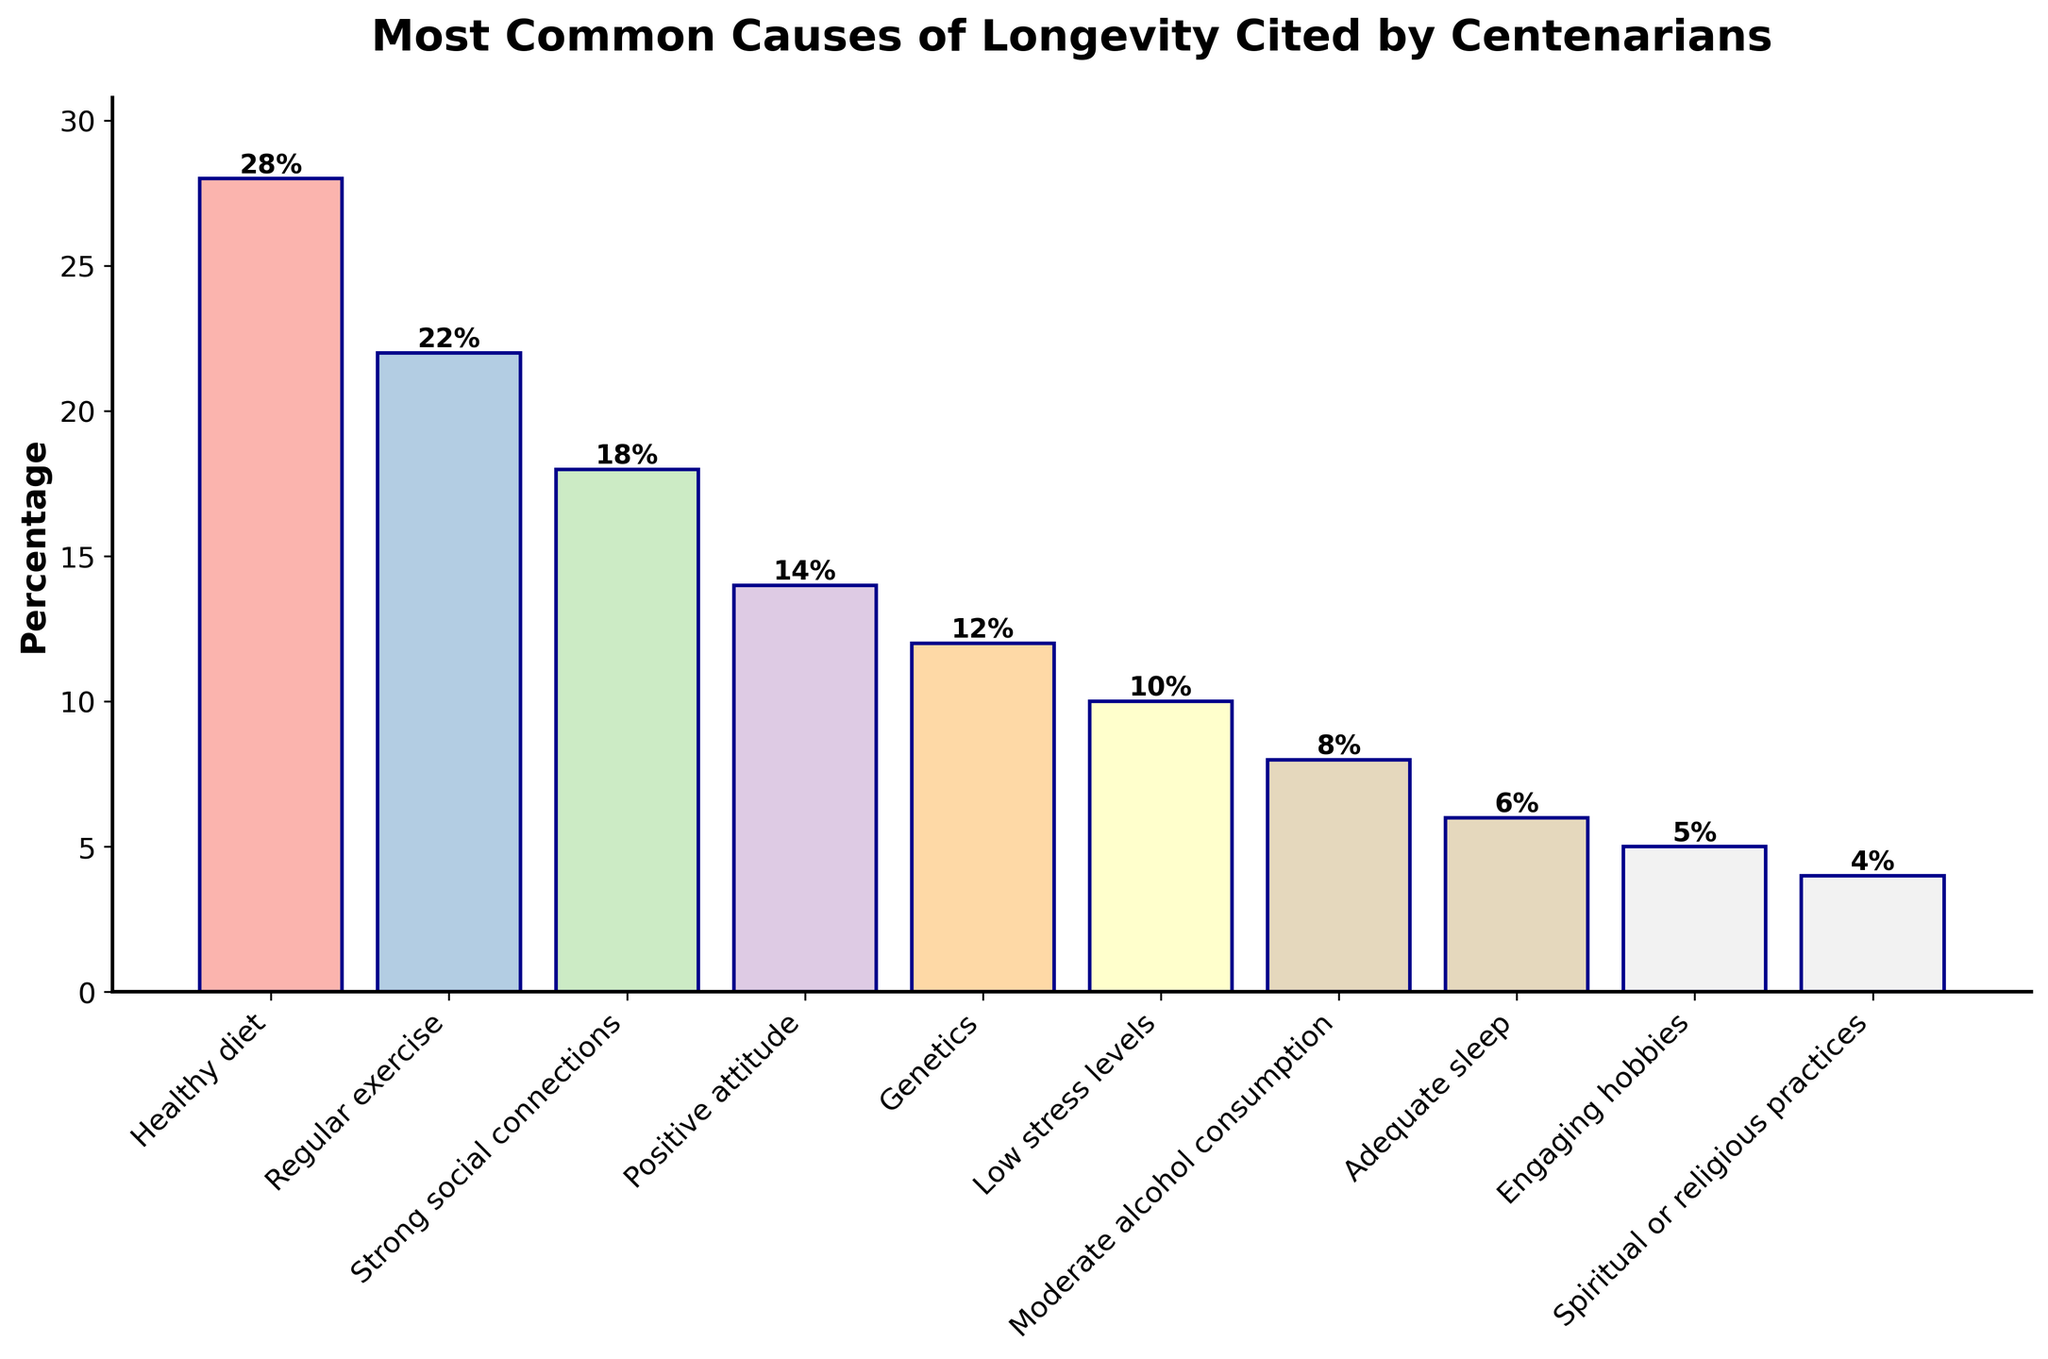What's the most common cause of longevity cited by centenarians? Identify the tallest bar in the chart. The "Healthy diet" bar is the tallest.
Answer: Healthy diet Which cause has the lowest percentage cited by centenarians? Identify the shortest bar in the chart. The "Spiritual or religious practices" bar is the shortest.
Answer: Spiritual or religious practices By how much does the percentage for "Healthy diet" exceed the percentage for "Genetics"? Subtract the percentage for "Genetics" from the percentage for "Healthy diet". (28% - 12% = 16%)
Answer: 16% Compare the percentage for "Regular exercise" and "Low stress levels". Which one is higher and by how much? Subtract the percentage for "Low stress levels" from "Regular exercise". (22% - 10% = 12%). "Regular exercise" is higher by 12%.
Answer: Regular exercise, 12% What is the total percentage for "Strong social connections" and "Positive attitude"? Add the percentages for "Strong social connections" and "Positive attitude". (18% + 14% = 32%)
Answer: 32% What is the combined percentage for "Moderate alcohol consumption" and "Adequate sleep"? Add the percentages for "Moderate alcohol consumption" and "Adequate sleep". (8% + 6% = 14%)
Answer: 14% Rank the top three causes of longevity based on the percentage of centenarians citing them. Order the percentages in descending order and pick the top three. The top three are: Healthy diet (28%), Regular exercise (22%), Strong social connections (18%).
Answer: Healthy diet, Regular exercise, Strong social connections Which cause has a percentage closest to the average percentage cited by all causes? Calculate the average percentage (sum all percentages and divide by the number of causes). Then find the cause with the percentage closest to this average. The average is (28 + 22 + 18 + 14 + 12 + 10 + 8 + 6 + 5 + 4)/10 = 12.7%. "Genetics" with 12% is the closest.
Answer: Genetics How much higher is the percentage for "Healthy diet" compared to the percentage for "Adequate sleep"? Subtract the percentage for "Adequate sleep" from the percentage for "Healthy diet". (28% - 6% = 22%)
Answer: 22% Which has a higher percentage: "Positive attitude" or "Low stress levels"? Compare the heights of the bars for "Positive attitude" and "Low stress levels". The bar for "Positive attitude" (14%) is taller than the bar for "Low stress levels" (10%).
Answer: Positive attitude 